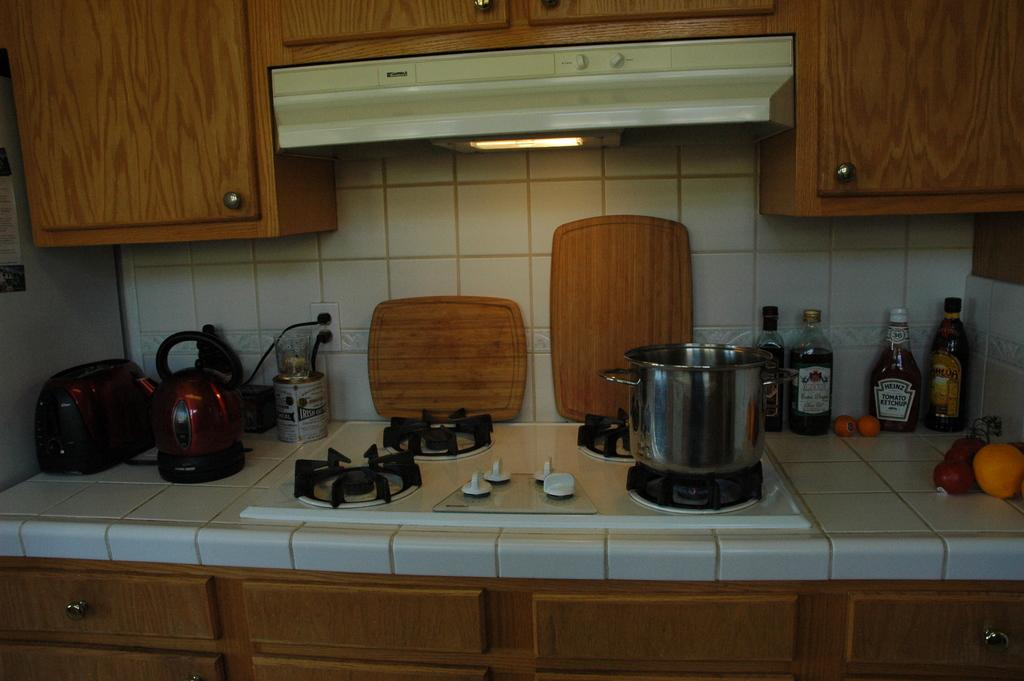<image>
Provide a brief description of the given image. a Heinz tomato ketchup that is next to others 